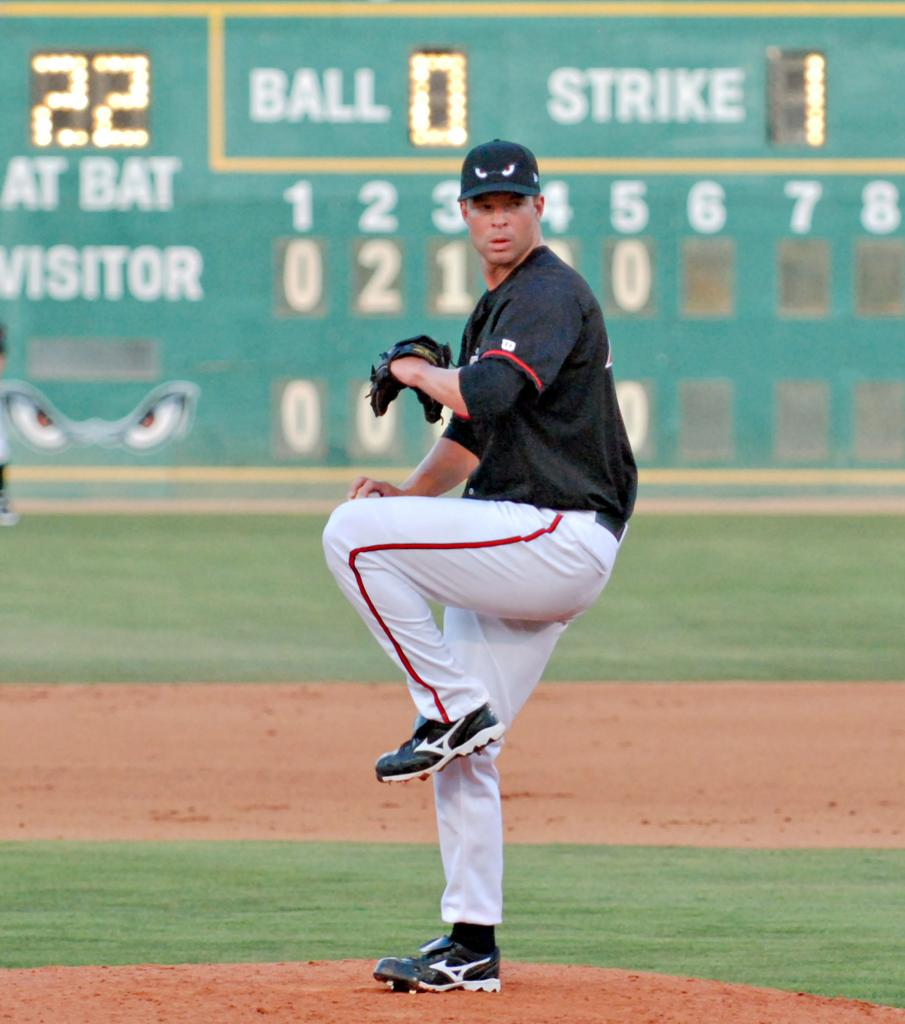<image>
Relay a brief, clear account of the picture shown. a player that is throwing a ball with the number 22 in the outfield 